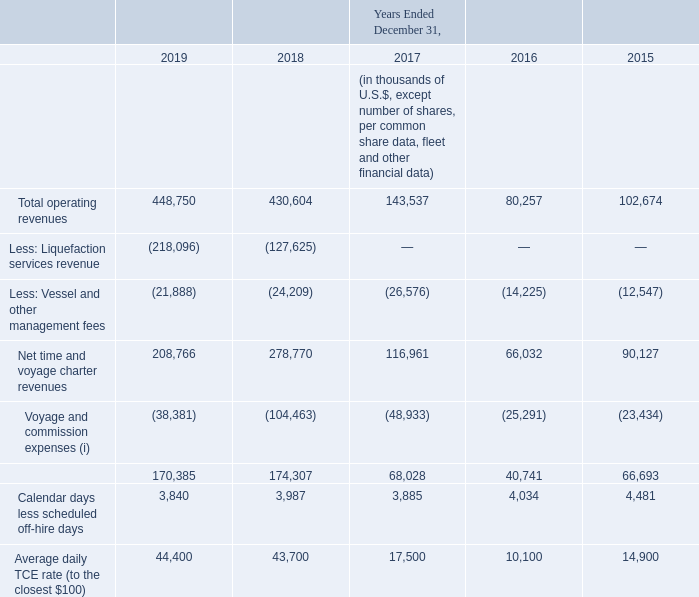Our calculation of TCE may not be comparable to that reported by other entities. The following table reconciles our total operating revenues to average daily TCE:
(i) "Voyage and commission expenses" is derived from the caption "Voyage, charterhire and commission expenses" and "Voyage, charterhire and commission expenses - collaborative arrangement" less (i) charterhire expenses (net of the effect of the related guarantee obligation) of $nil, $nil and $12.4 million for the years ended December 31, 2019, 2018 and 2017, respectively, which arose on the charter-back of the Golar Grand from Golar Partners, and (ii) voyage and commission expenses in relation to the Hilli Episeyo of $0.5 million, $1.4 million and $nil for the years ended December 31, 2019, 2018 and 2017, respectively.
(5) We calculate average daily vessel operating costs by dividing vessel operating costs by the number of calendar days. Calendar days exclude those from vessels chartered in where the vessel operating costs are borne by the legal owner, and those of vessels undergoing conversion.
In which years was the total operating revenues to average daily TCE recorded for? 2019, 2018, 2017, 2016, 2015. How was the average daily vessel operating cost calculated? By dividing vessel operating costs by the number of calendar days. What was the charterhire expenses in 2017? $12.4 million. In which year was the net time and voyage charter revenues the highest? 278,770 >208,766 > 116,961> 90,127> 66,032
Answer: 2018. What was the change in total operating revenues from 2016 to 2017?
Answer scale should be: thousand. 143,537 - 80,257 
Answer: 63280. What was the percentage change in average daily TCE rate from 2018 to 2019?
Answer scale should be: percent. (44,400 - 43,700)/43,700 
Answer: 1.6. 